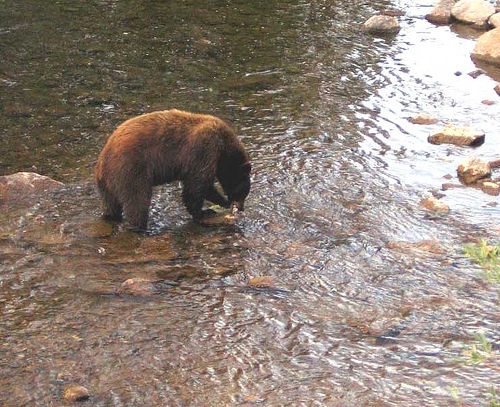<image>Which direction is the river flowing? I don't know which direction the river is flowing. The direction could be north, south, west, downstream or away from bear. Which direction is the river flowing? I don't know which direction the river is flowing. It can be seen flowing downstream in some answers. 